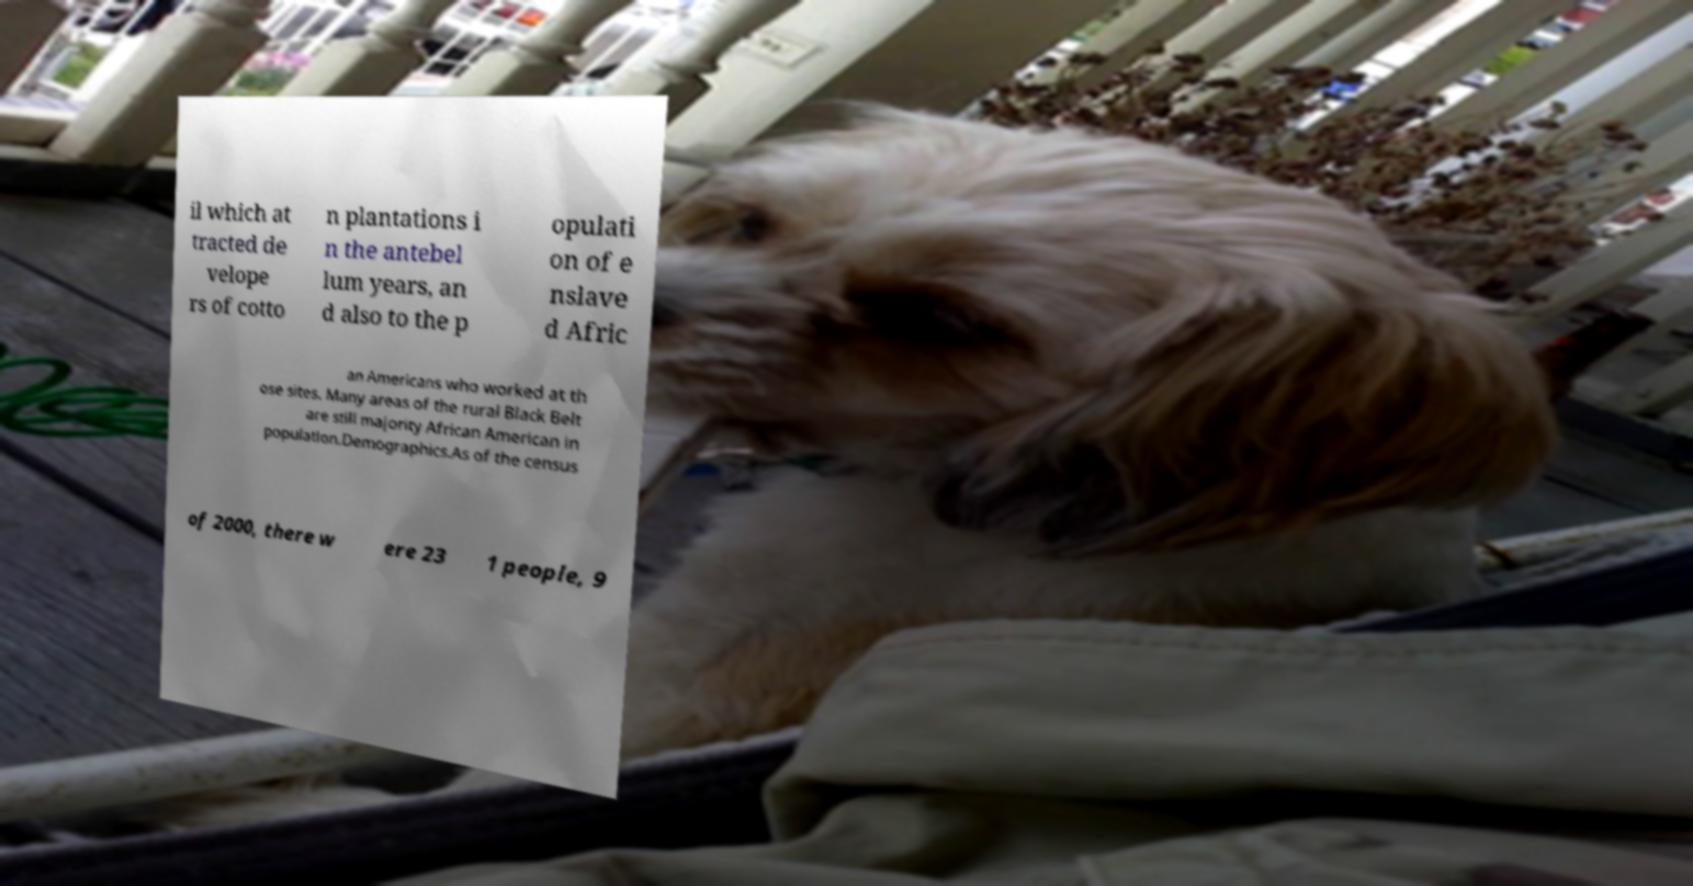I need the written content from this picture converted into text. Can you do that? il which at tracted de velope rs of cotto n plantations i n the antebel lum years, an d also to the p opulati on of e nslave d Afric an Americans who worked at th ose sites. Many areas of the rural Black Belt are still majority African American in population.Demographics.As of the census of 2000, there w ere 23 1 people, 9 